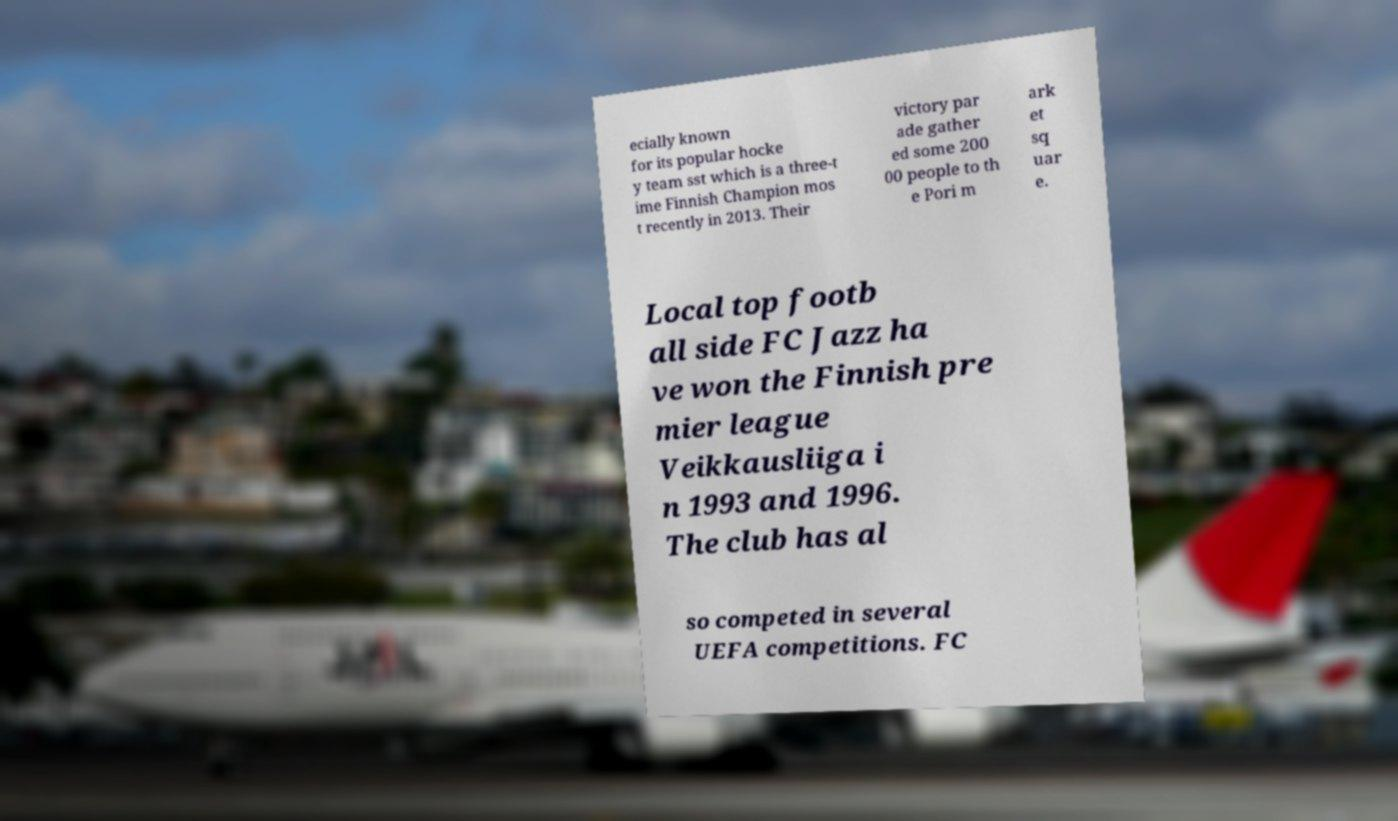I need the written content from this picture converted into text. Can you do that? ecially known for its popular hocke y team sst which is a three-t ime Finnish Champion mos t recently in 2013. Their victory par ade gather ed some 200 00 people to th e Pori m ark et sq uar e. Local top footb all side FC Jazz ha ve won the Finnish pre mier league Veikkausliiga i n 1993 and 1996. The club has al so competed in several UEFA competitions. FC 